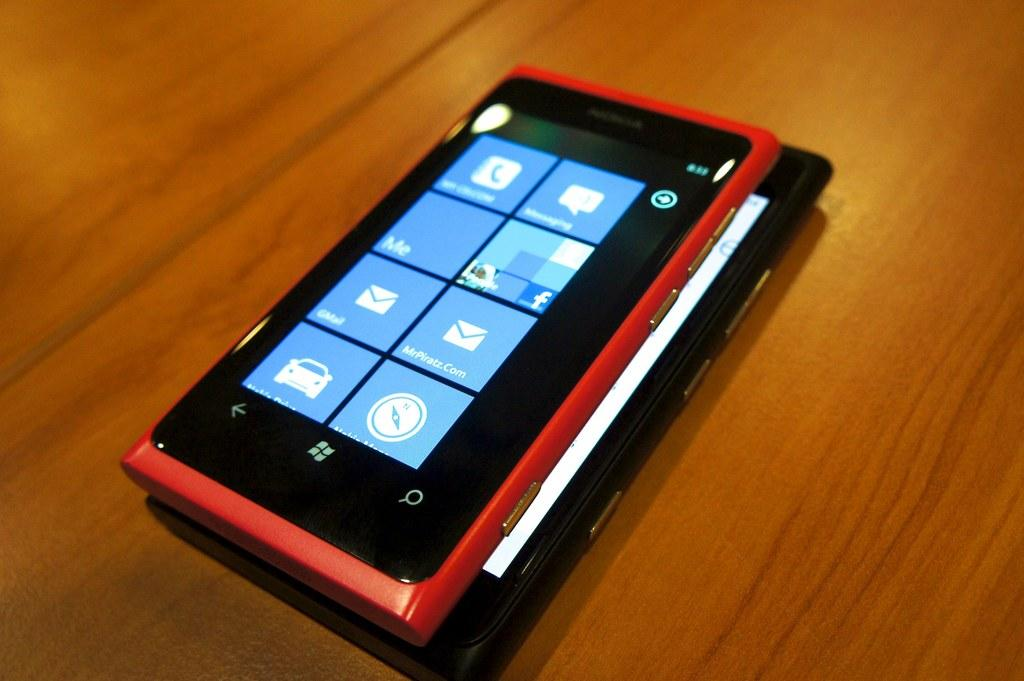Provide a one-sentence caption for the provided image. A windows phone and screen showing the menu on the phone. 